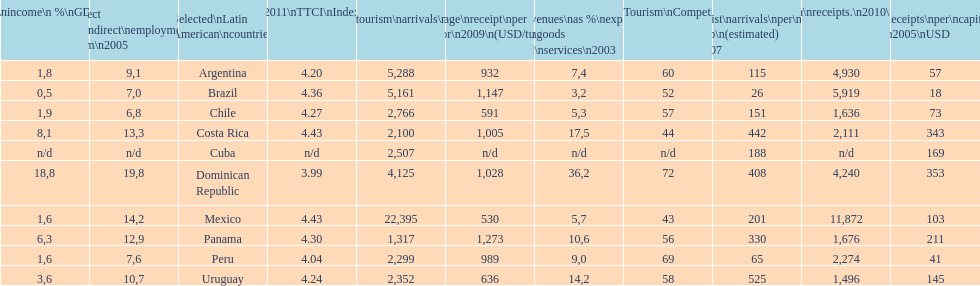What country had the least arrivals per 1000 inhabitants in 2007(estimated)? Brazil. 